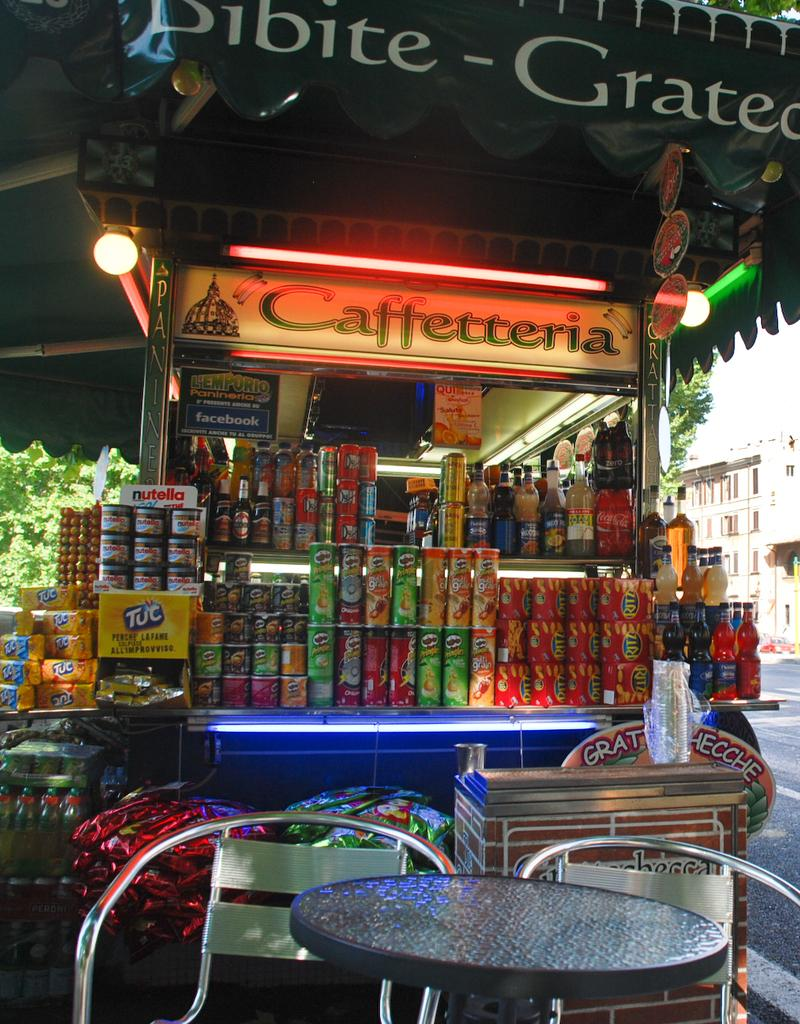Provide a one-sentence caption for the provided image. Sundries are stacked on a Caffetteria stand under an awning by the side of a street. 